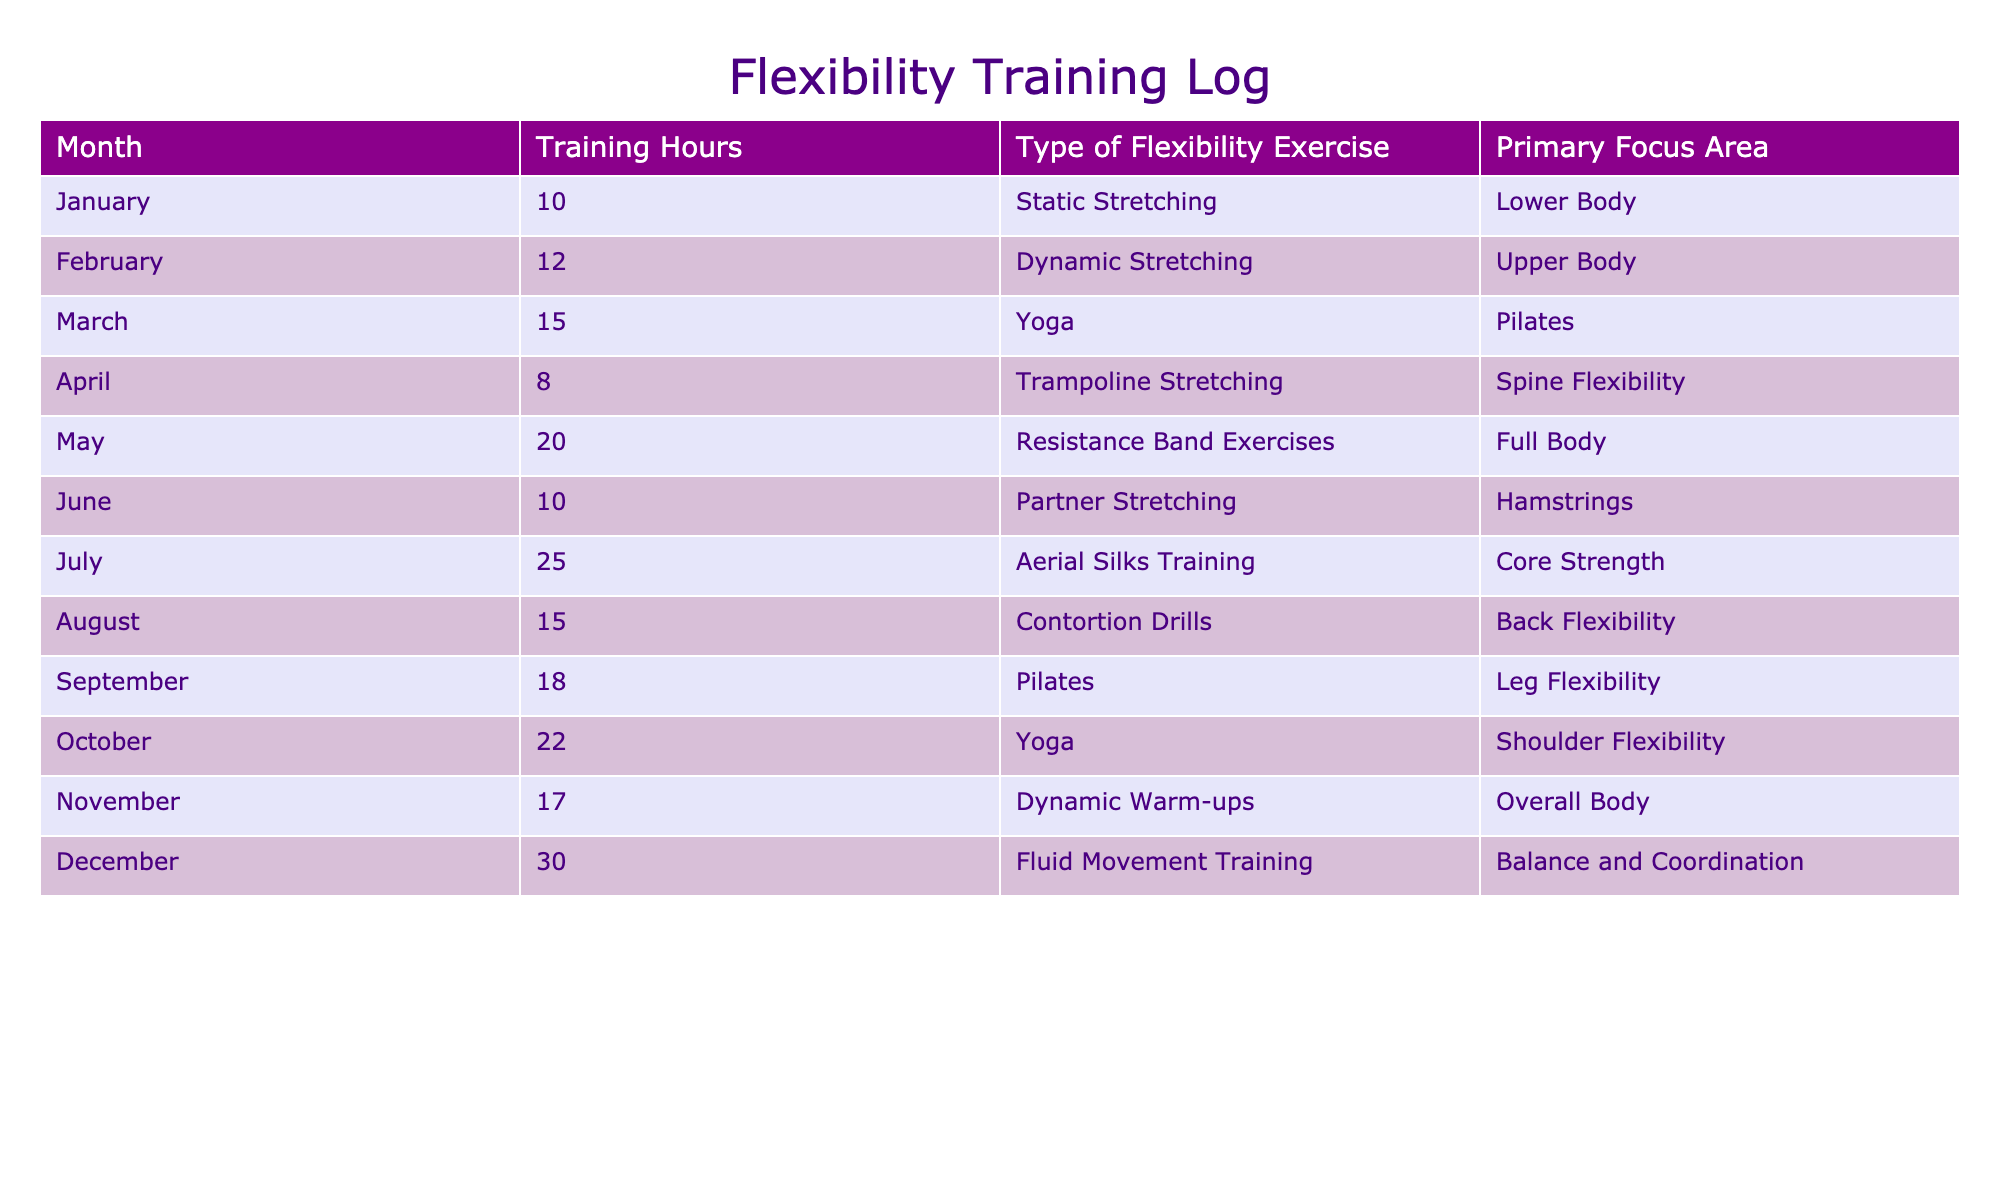What month had the highest training hours? By reviewing the "Training Hours" column, the highest value is 30 in December.
Answer: December How many hours were dedicated to dynamic stretching in total across the year? The table shows that dynamic stretching occurred in February (12 hours) and November (17 hours). Adding these gives 12 + 17 = 29 hours.
Answer: 29 Was static stretching the primary focus area in more months than fluid movement training? Static stretching is listed in January only, while fluid movement training is listed in December only. Thus, static stretching occurred in 1 month, and fluid movement training also occurred in 1 month, making the answer no.
Answer: No What was the average training hours for flexibility exercises over the year? To find the average: the total training hours are 10 + 12 + 15 + 8 + 20 + 10 + 25 + 15 + 18 + 22 + 17 + 30 =  252. There are 12 months, so the average is 252 / 12 = 21.
Answer: 21 Which type of exercise was performed in March and what was its primary focus area? In March, the type of exercise was Pilates, and the primary focus area was Leg Flexibility, as indicated in the respective columns.
Answer: Pilates, Leg Flexibility How many exercises focused on 'Core Strength' and 'Balance and Coordination' combined? The exercises that focused on 'Core Strength' and 'Balance and Coordination' are "Aerial Silks Training" (July) and "Fluid Movement Training" (December), respectively. Therefore, there are 2 exercises focusing on these areas.
Answer: 2 Which month saw the least training hours and what type of exercise was it? Referring to the "Training Hours" column, April had the least hours at 8, and the type of exercise was Trampoline Stretching.
Answer: April, Trampoline Stretching Was there a month with 25 training hours, and if so, which month? Yes, July had 25 training hours, indicated directly in the table under the "Training Hours" column.
Answer: Yes, July 